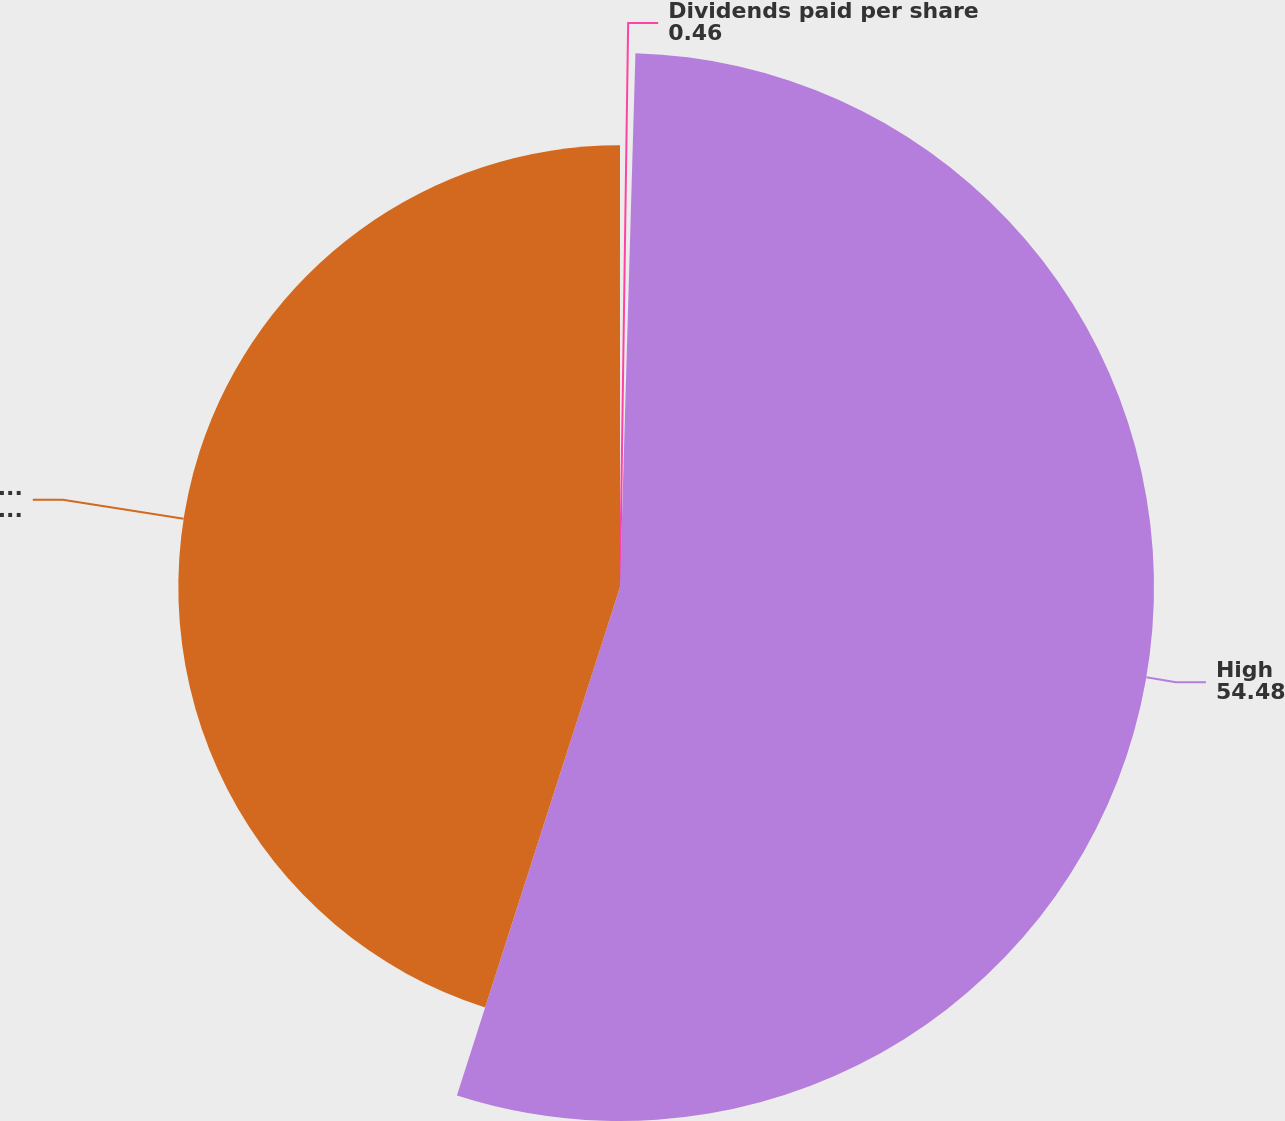Convert chart to OTSL. <chart><loc_0><loc_0><loc_500><loc_500><pie_chart><fcel>Dividends paid per share<fcel>High<fcel>Low<nl><fcel>0.46%<fcel>54.48%<fcel>45.06%<nl></chart> 